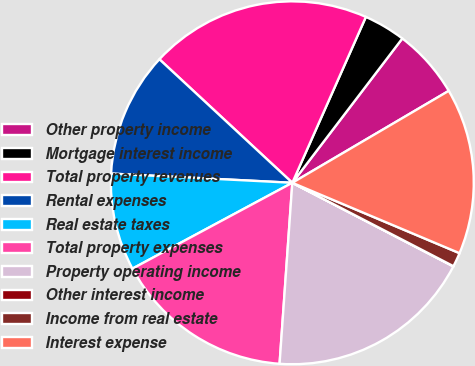Convert chart. <chart><loc_0><loc_0><loc_500><loc_500><pie_chart><fcel>Other property income<fcel>Mortgage interest income<fcel>Total property revenues<fcel>Rental expenses<fcel>Real estate taxes<fcel>Total property expenses<fcel>Property operating income<fcel>Other interest income<fcel>Income from real estate<fcel>Interest expense<nl><fcel>6.18%<fcel>3.72%<fcel>19.73%<fcel>11.11%<fcel>8.65%<fcel>16.04%<fcel>18.5%<fcel>0.02%<fcel>1.26%<fcel>14.8%<nl></chart> 